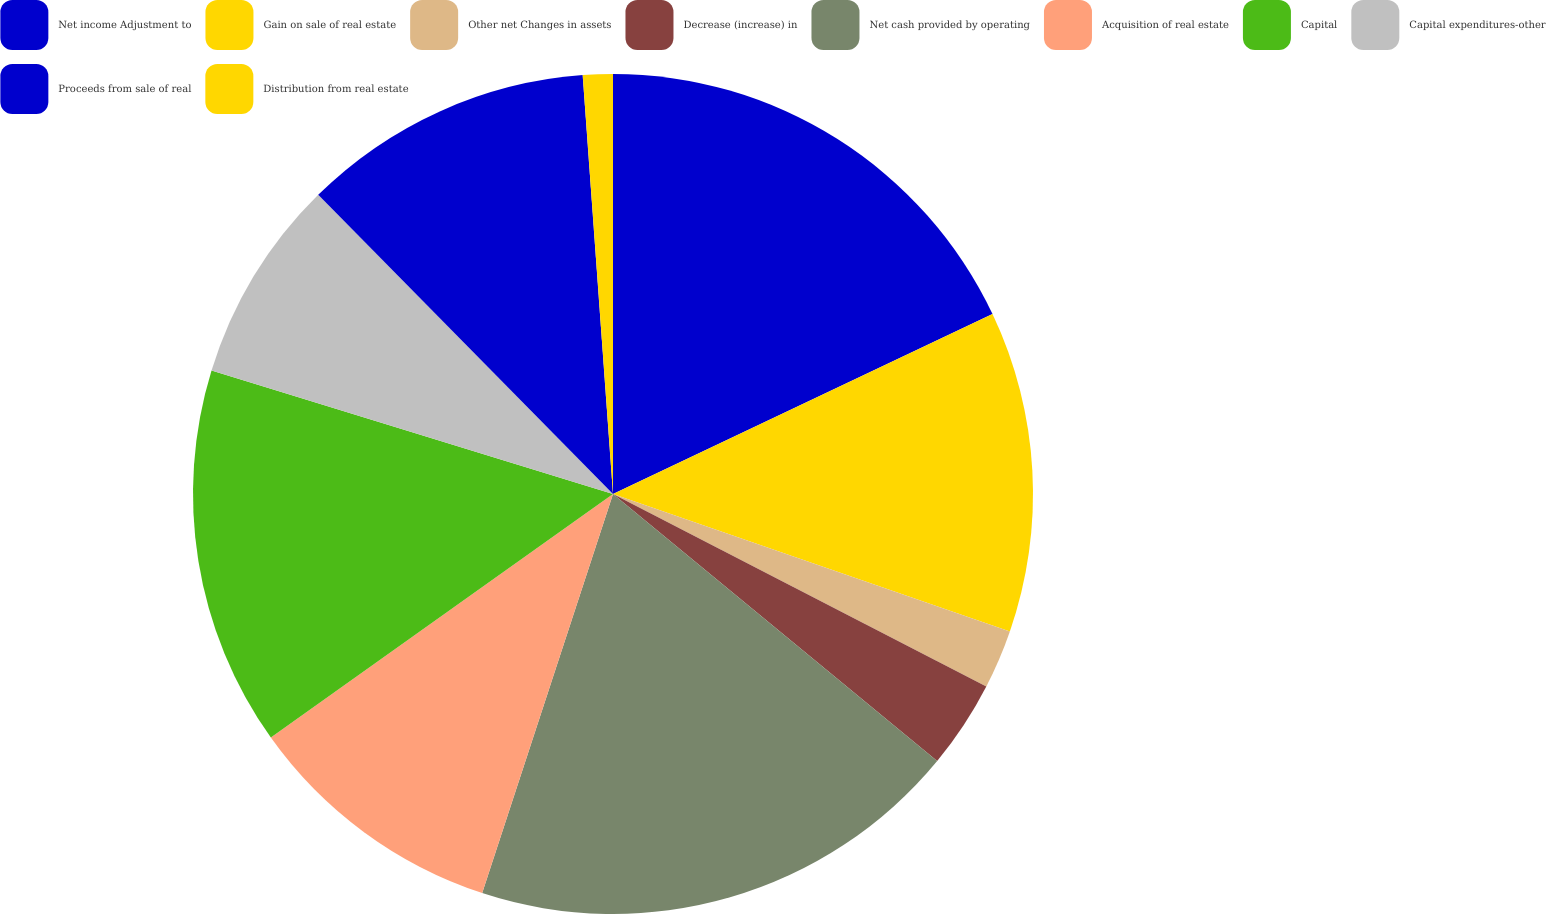<chart> <loc_0><loc_0><loc_500><loc_500><pie_chart><fcel>Net income Adjustment to<fcel>Gain on sale of real estate<fcel>Other net Changes in assets<fcel>Decrease (increase) in<fcel>Net cash provided by operating<fcel>Acquisition of real estate<fcel>Capital<fcel>Capital expenditures-other<fcel>Proceeds from sale of real<fcel>Distribution from real estate<nl><fcel>17.95%<fcel>12.35%<fcel>2.27%<fcel>3.39%<fcel>19.07%<fcel>10.11%<fcel>14.59%<fcel>7.87%<fcel>11.23%<fcel>1.15%<nl></chart> 